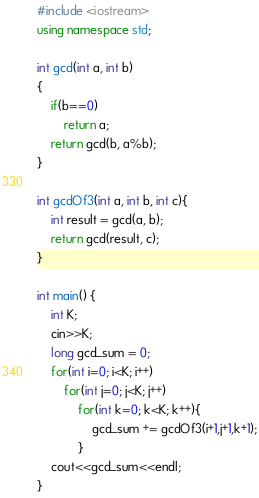<code> <loc_0><loc_0><loc_500><loc_500><_C++_>#include <iostream>
using namespace std;

int gcd(int a, int b)
{
    if(b==0)
        return a;
    return gcd(b, a%b);
}

int gcdOf3(int a, int b, int c){
    int result = gcd(a, b);
    return gcd(result, c);
}

int main() {
    int K;
    cin>>K;
    long gcd_sum = 0;
    for(int i=0; i<K; i++)
        for(int j=0; j<K; j++)
            for(int k=0; k<K; k++){
                gcd_sum += gcdOf3(i+1,j+1,k+1);
            }
    cout<<gcd_sum<<endl;
}
</code> 